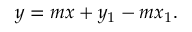<formula> <loc_0><loc_0><loc_500><loc_500>y = m x + y _ { 1 } - m x _ { 1 } .</formula> 